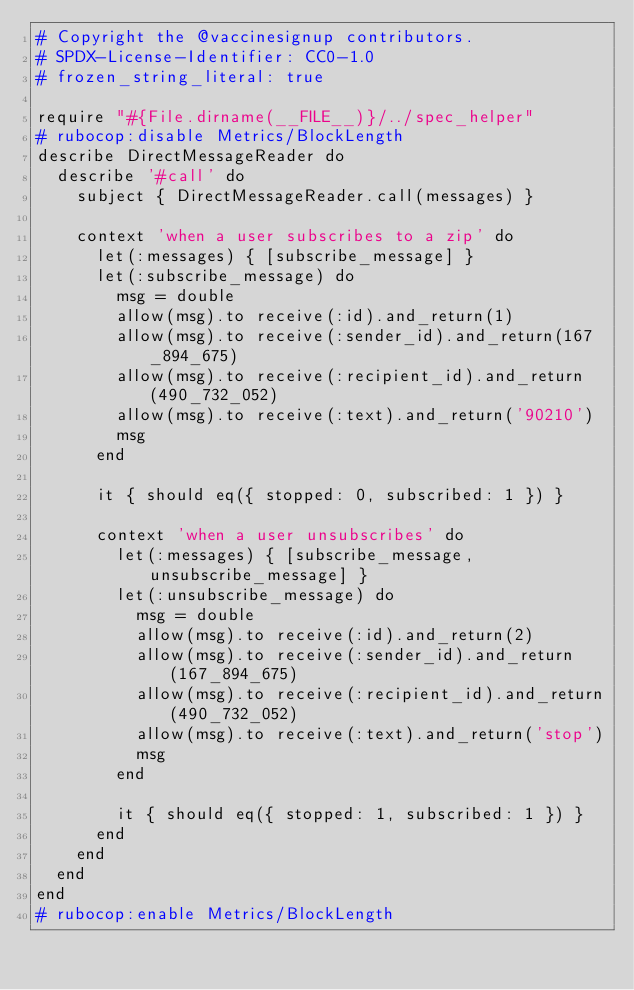Convert code to text. <code><loc_0><loc_0><loc_500><loc_500><_Ruby_># Copyright the @vaccinesignup contributors.
# SPDX-License-Identifier: CC0-1.0
# frozen_string_literal: true

require "#{File.dirname(__FILE__)}/../spec_helper"
# rubocop:disable Metrics/BlockLength
describe DirectMessageReader do
  describe '#call' do
    subject { DirectMessageReader.call(messages) }

    context 'when a user subscribes to a zip' do
      let(:messages) { [subscribe_message] }
      let(:subscribe_message) do
        msg = double
        allow(msg).to receive(:id).and_return(1)
        allow(msg).to receive(:sender_id).and_return(167_894_675)
        allow(msg).to receive(:recipient_id).and_return(490_732_052)
        allow(msg).to receive(:text).and_return('90210')
        msg
      end

      it { should eq({ stopped: 0, subscribed: 1 }) }

      context 'when a user unsubscribes' do
        let(:messages) { [subscribe_message, unsubscribe_message] }
        let(:unsubscribe_message) do
          msg = double
          allow(msg).to receive(:id).and_return(2)
          allow(msg).to receive(:sender_id).and_return(167_894_675)
          allow(msg).to receive(:recipient_id).and_return(490_732_052)
          allow(msg).to receive(:text).and_return('stop')
          msg
        end

        it { should eq({ stopped: 1, subscribed: 1 }) }
      end
    end
  end
end
# rubocop:enable Metrics/BlockLength
</code> 